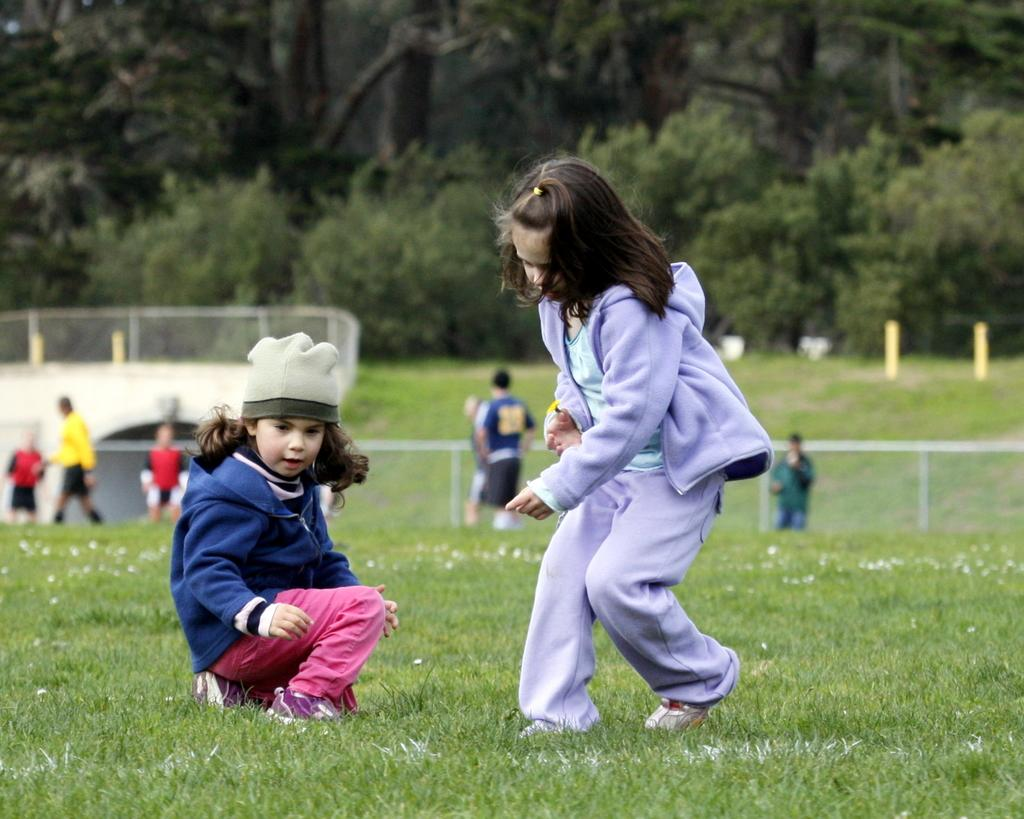How many girls are in the foreground of the image? There are two girls in the foreground of the image. What are the positions of the girls in the foreground? One girl is standing, and the other is squatting. What can be seen in the background of the image? In the background, there are persons standing, fencing, poles, grass, and trees. What religious symbol can be seen in the image? There is no religious symbol present in the image. What invention is being used by the girls in the image? There is no invention being used by the girls in the image; they are simply standing and squatting. 